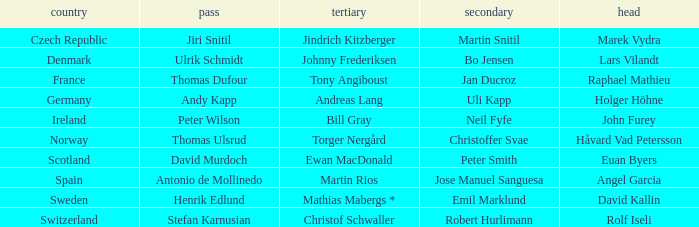In which third did angel garcia lead? Martin Rios. 